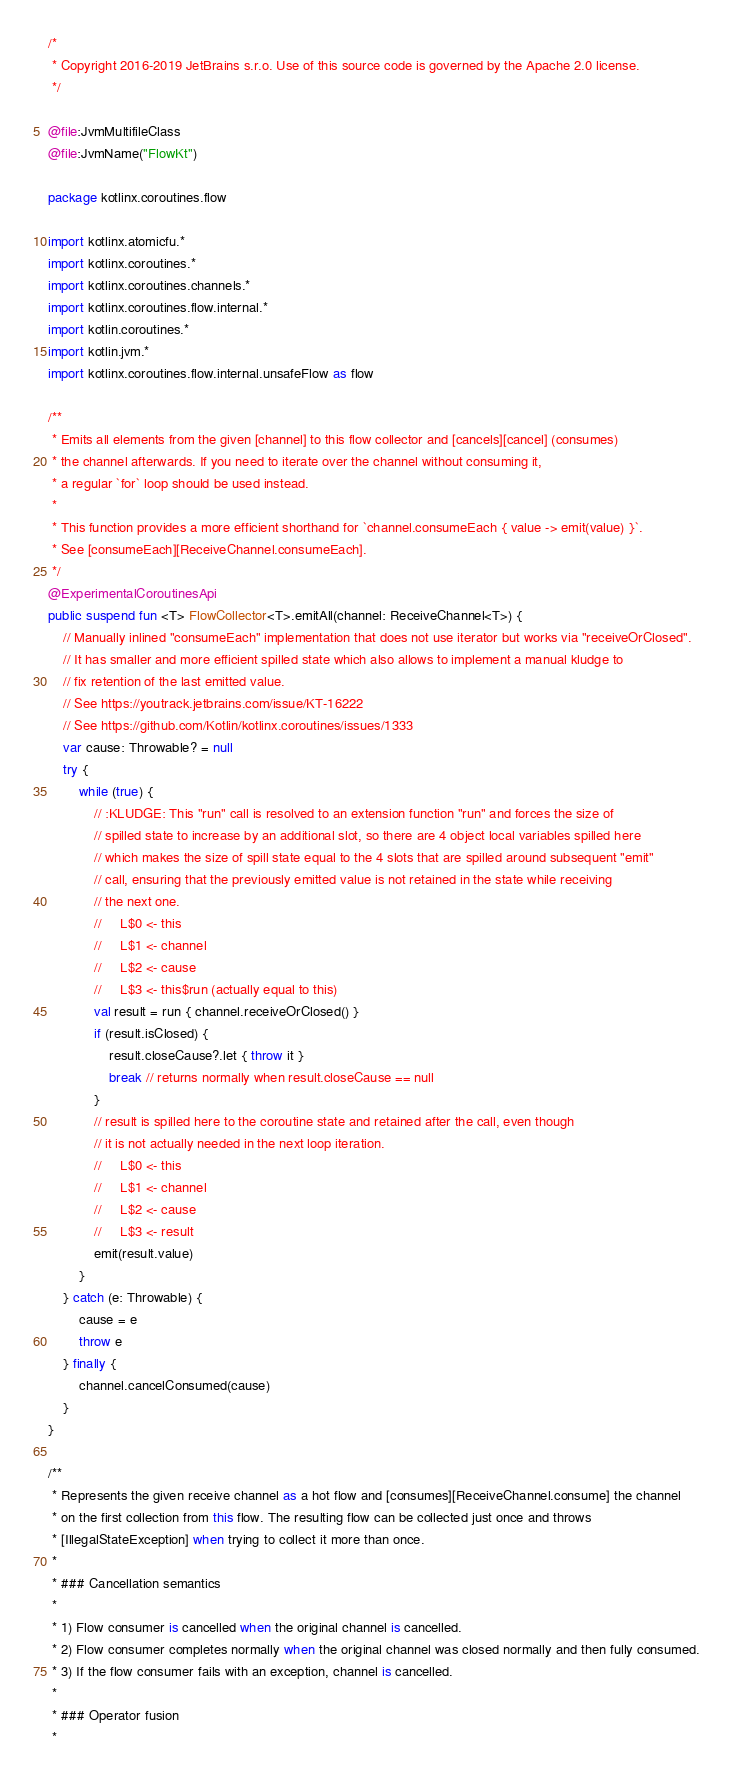<code> <loc_0><loc_0><loc_500><loc_500><_Kotlin_>/*
 * Copyright 2016-2019 JetBrains s.r.o. Use of this source code is governed by the Apache 2.0 license.
 */

@file:JvmMultifileClass
@file:JvmName("FlowKt")

package kotlinx.coroutines.flow

import kotlinx.atomicfu.*
import kotlinx.coroutines.*
import kotlinx.coroutines.channels.*
import kotlinx.coroutines.flow.internal.*
import kotlin.coroutines.*
import kotlin.jvm.*
import kotlinx.coroutines.flow.internal.unsafeFlow as flow

/**
 * Emits all elements from the given [channel] to this flow collector and [cancels][cancel] (consumes)
 * the channel afterwards. If you need to iterate over the channel without consuming it,
 * a regular `for` loop should be used instead.
 *
 * This function provides a more efficient shorthand for `channel.consumeEach { value -> emit(value) }`.
 * See [consumeEach][ReceiveChannel.consumeEach].
 */
@ExperimentalCoroutinesApi
public suspend fun <T> FlowCollector<T>.emitAll(channel: ReceiveChannel<T>) {
    // Manually inlined "consumeEach" implementation that does not use iterator but works via "receiveOrClosed".
    // It has smaller and more efficient spilled state which also allows to implement a manual kludge to
    // fix retention of the last emitted value.
    // See https://youtrack.jetbrains.com/issue/KT-16222
    // See https://github.com/Kotlin/kotlinx.coroutines/issues/1333
    var cause: Throwable? = null
    try {
        while (true) {
            // :KLUDGE: This "run" call is resolved to an extension function "run" and forces the size of
            // spilled state to increase by an additional slot, so there are 4 object local variables spilled here
            // which makes the size of spill state equal to the 4 slots that are spilled around subsequent "emit"
            // call, ensuring that the previously emitted value is not retained in the state while receiving
            // the next one.
            //     L$0 <- this
            //     L$1 <- channel
            //     L$2 <- cause
            //     L$3 <- this$run (actually equal to this)
            val result = run { channel.receiveOrClosed() }
            if (result.isClosed) {
                result.closeCause?.let { throw it }
                break // returns normally when result.closeCause == null
            }
            // result is spilled here to the coroutine state and retained after the call, even though
            // it is not actually needed in the next loop iteration.
            //     L$0 <- this
            //     L$1 <- channel
            //     L$2 <- cause
            //     L$3 <- result
            emit(result.value)
        }
    } catch (e: Throwable) {
        cause = e
        throw e
    } finally {
        channel.cancelConsumed(cause)
    }
}

/**
 * Represents the given receive channel as a hot flow and [consumes][ReceiveChannel.consume] the channel
 * on the first collection from this flow. The resulting flow can be collected just once and throws
 * [IllegalStateException] when trying to collect it more than once.
 *
 * ### Cancellation semantics
 *
 * 1) Flow consumer is cancelled when the original channel is cancelled.
 * 2) Flow consumer completes normally when the original channel was closed normally and then fully consumed.
 * 3) If the flow consumer fails with an exception, channel is cancelled.
 *
 * ### Operator fusion
 *</code> 